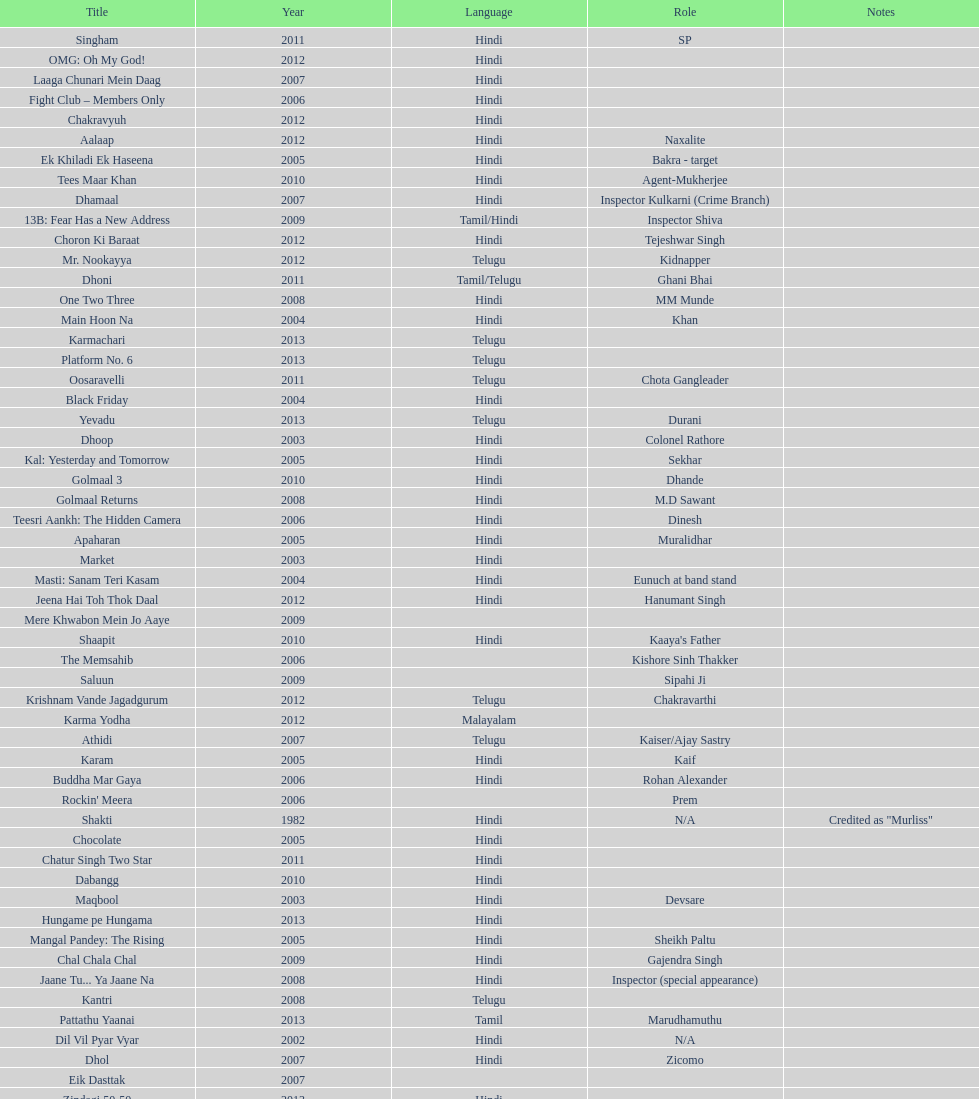What was the last malayalam film this actor starred in? Karma Yodha. 